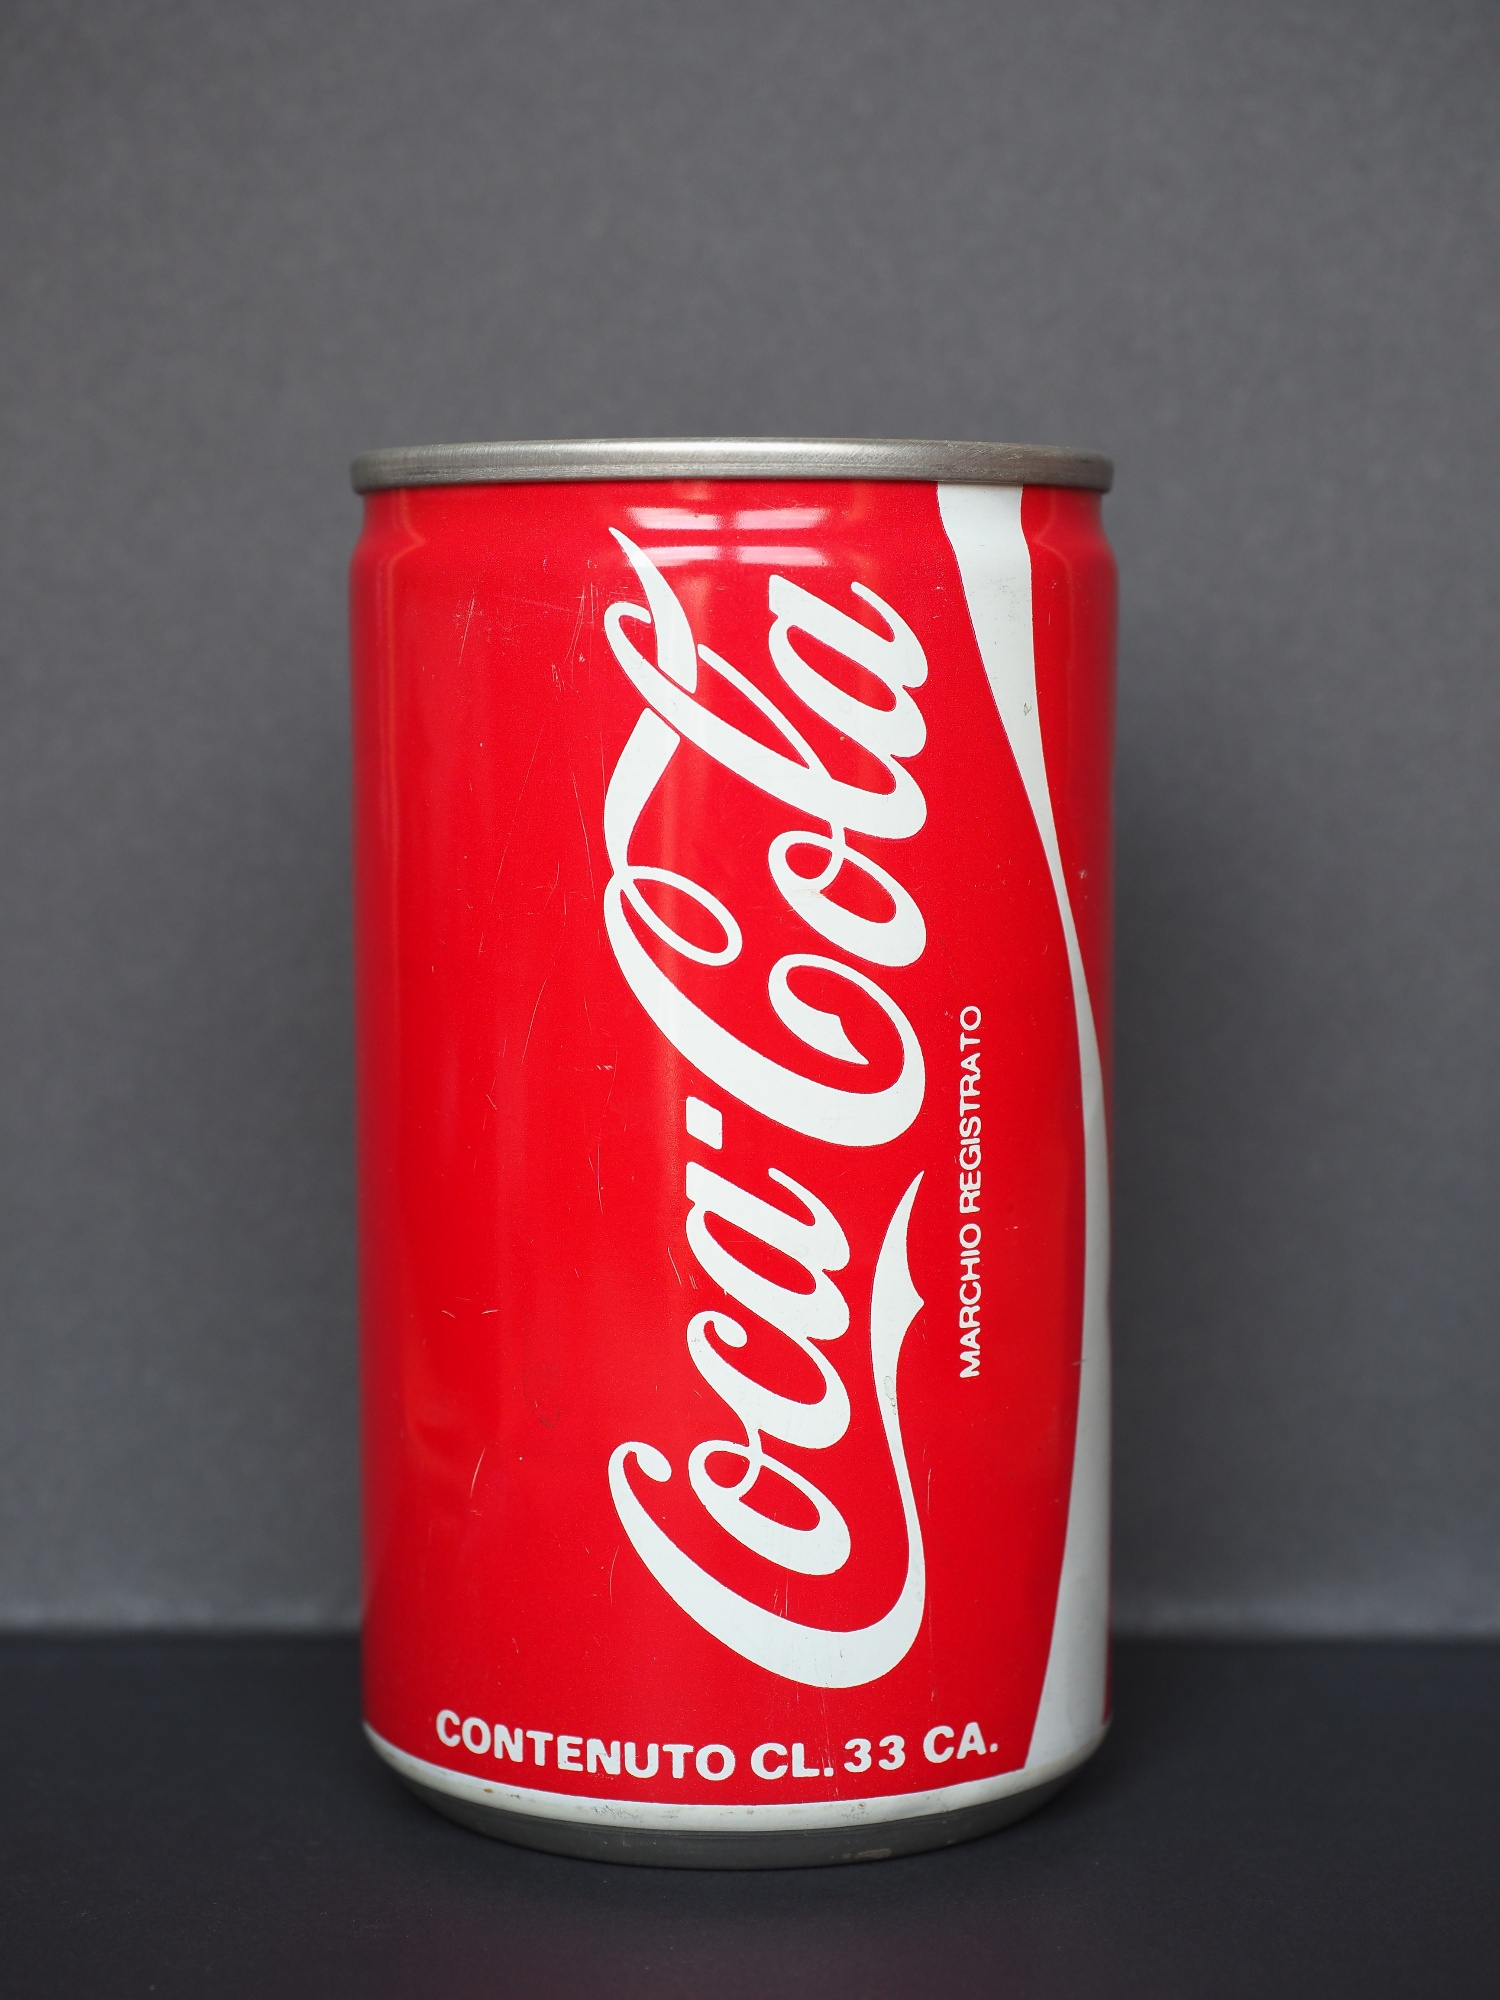Can you tell a realistic scenario related to this image in a more detailed way? James had been working tirelessly in his garage on a sweltering summer afternoon. Despite the heat, he was determined to finish his project. Beads of sweat trickled down his forehead as he meticulously fixed the old, rusty bike. His throat was parched, and just as he was about to call it a day, his eyes landed on the Coca Cola can on his workbench. He reached for it, feeling the chilled condensation against his hand. The familiar hiss of carbonation greeted him as he popped the tab, followed by the crisp sound of the first sip. The cool, fizzy liquid was an immediate relief, invigorating him to push through and finish his work. That brief moment of refreshment reminded him why he always kept a stock of Coca Cola in his fridge – it was the perfect companion for days like these. 